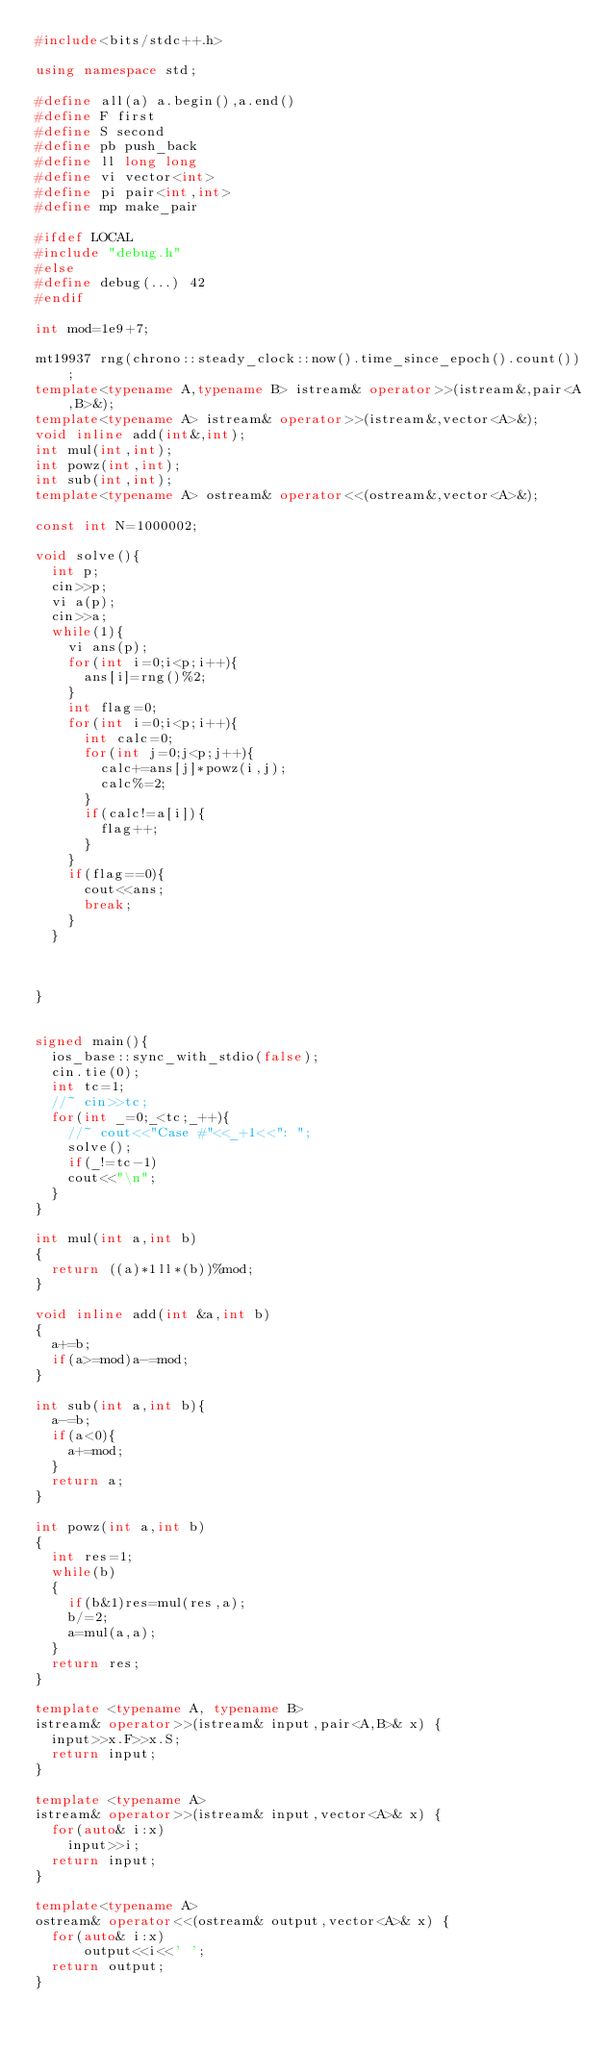Convert code to text. <code><loc_0><loc_0><loc_500><loc_500><_C++_>#include<bits/stdc++.h>
 
using namespace std;
 
#define all(a) a.begin(),a.end()
#define F first
#define S second
#define pb push_back
#define ll long long
#define vi vector<int>
#define pi pair<int,int>
#define mp make_pair

#ifdef LOCAL
#include "debug.h"
#else
#define debug(...) 42
#endif
 
int mod=1e9+7;
 
mt19937 rng(chrono::steady_clock::now().time_since_epoch().count());
template<typename A,typename B> istream& operator>>(istream&,pair<A,B>&);
template<typename A> istream& operator>>(istream&,vector<A>&);
void inline add(int&,int);
int mul(int,int);
int powz(int,int);
int sub(int,int);
template<typename A> ostream& operator<<(ostream&,vector<A>&);
 
const int N=1000002;

void solve(){
	int p;
	cin>>p;
	vi a(p);
	cin>>a;
	while(1){
		vi ans(p);
		for(int i=0;i<p;i++){
			ans[i]=rng()%2;
		}
		int flag=0;
		for(int i=0;i<p;i++){
			int calc=0;
			for(int j=0;j<p;j++){
				calc+=ans[j]*powz(i,j);
				calc%=2;
			}
			if(calc!=a[i]){
				flag++;
			}
		}
		if(flag==0){
			cout<<ans;
			break;
		}
	}
	
	
	
}

 
signed main(){
	ios_base::sync_with_stdio(false);
	cin.tie(0);
	int tc=1;
	//~ cin>>tc;
	for(int _=0;_<tc;_++){
		//~ cout<<"Case #"<<_+1<<": ";
		solve();
		if(_!=tc-1)
		cout<<"\n";
	}
}
 
int mul(int a,int b)
{
	return ((a)*1ll*(b))%mod;
}
 
void inline add(int &a,int b)
{
	a+=b;
	if(a>=mod)a-=mod;
}
 
int sub(int a,int b){
	a-=b;
	if(a<0){
		a+=mod;
	}
	return a;
}
 
int powz(int a,int b)
{
	int res=1;
	while(b)
	{
		if(b&1)res=mul(res,a);
		b/=2;
		a=mul(a,a);
	}
	return res;
}
 
template <typename A, typename B>
istream& operator>>(istream& input,pair<A,B>& x) {
	input>>x.F>>x.S;
	return input;
}
 
template <typename A>
istream& operator>>(istream& input,vector<A>& x) {
	for(auto& i:x)
		input>>i;
	return input;
}
 
template<typename A>
ostream& operator<<(ostream& output,vector<A>& x) {
	for(auto& i:x)
	    output<<i<<' ';
	return output;
}
</code> 